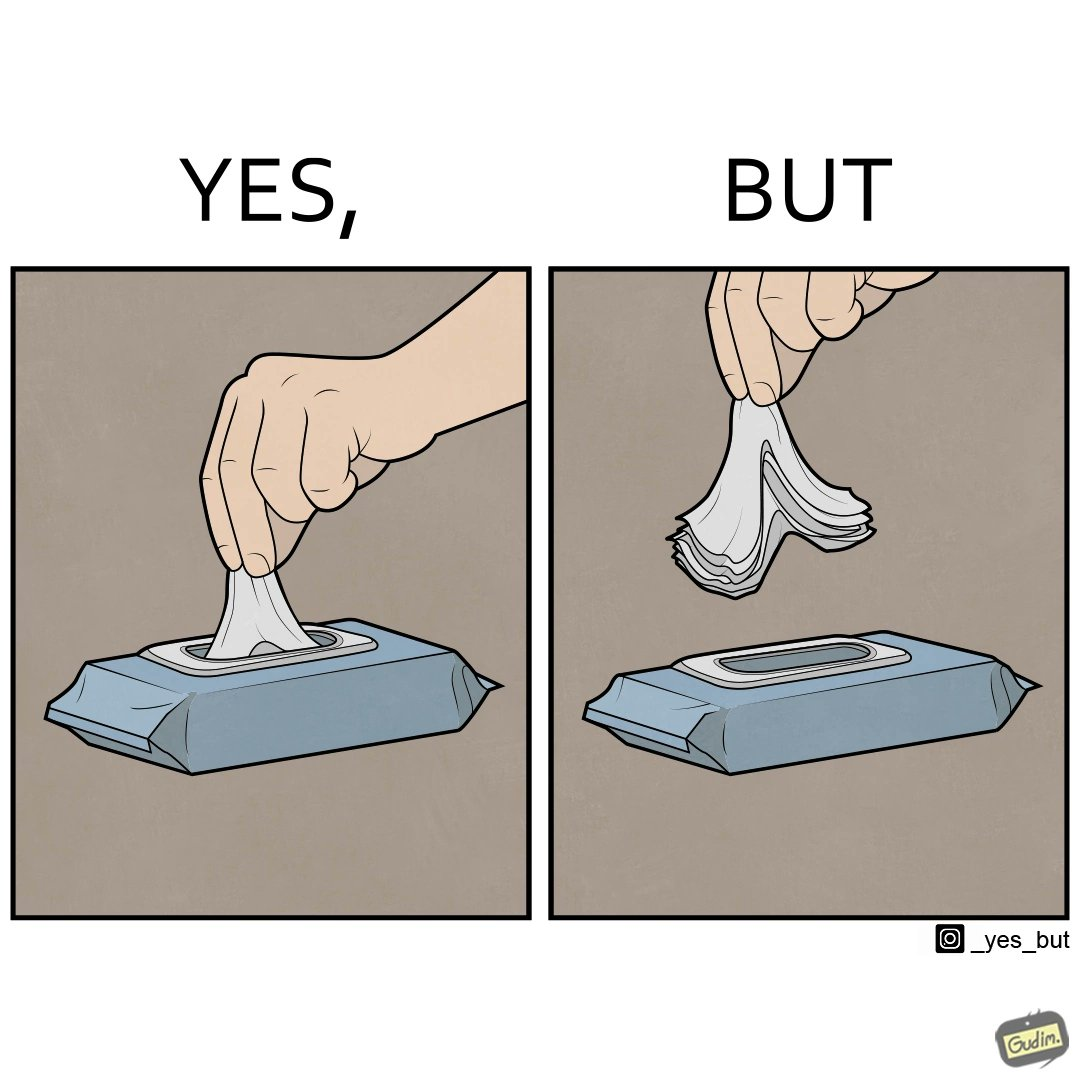Describe the content of this image. The image is ironic, because even when there is a need of only one napkin but the napkins are so tightly packed that more than one napkin gets out sticked together 